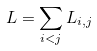Convert formula to latex. <formula><loc_0><loc_0><loc_500><loc_500>L = \sum _ { i < j } L _ { i , j }</formula> 